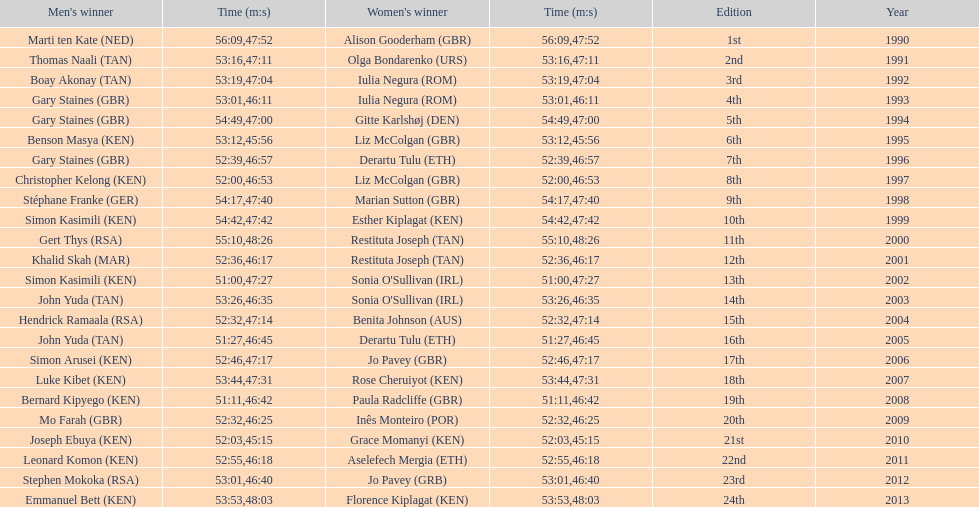Who is the male winner listed before gert thys? Simon Kasimili. 